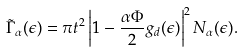Convert formula to latex. <formula><loc_0><loc_0><loc_500><loc_500>\tilde { \Gamma } _ { \alpha } ( \epsilon ) = \pi t ^ { 2 } \left | 1 - \frac { \alpha \Phi } { 2 } g _ { d } ( \epsilon ) \right | ^ { 2 } N _ { \alpha } ( \epsilon ) .</formula> 